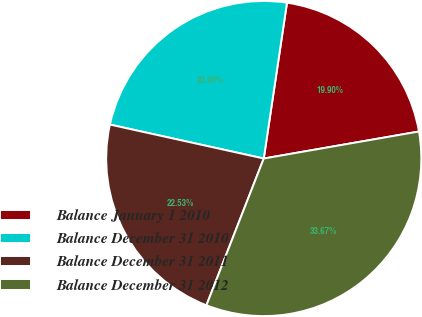<chart> <loc_0><loc_0><loc_500><loc_500><pie_chart><fcel>Balance January 1 2010<fcel>Balance December 31 2010<fcel>Balance December 31 2011<fcel>Balance December 31 2012<nl><fcel>19.9%<fcel>23.9%<fcel>22.53%<fcel>33.67%<nl></chart> 